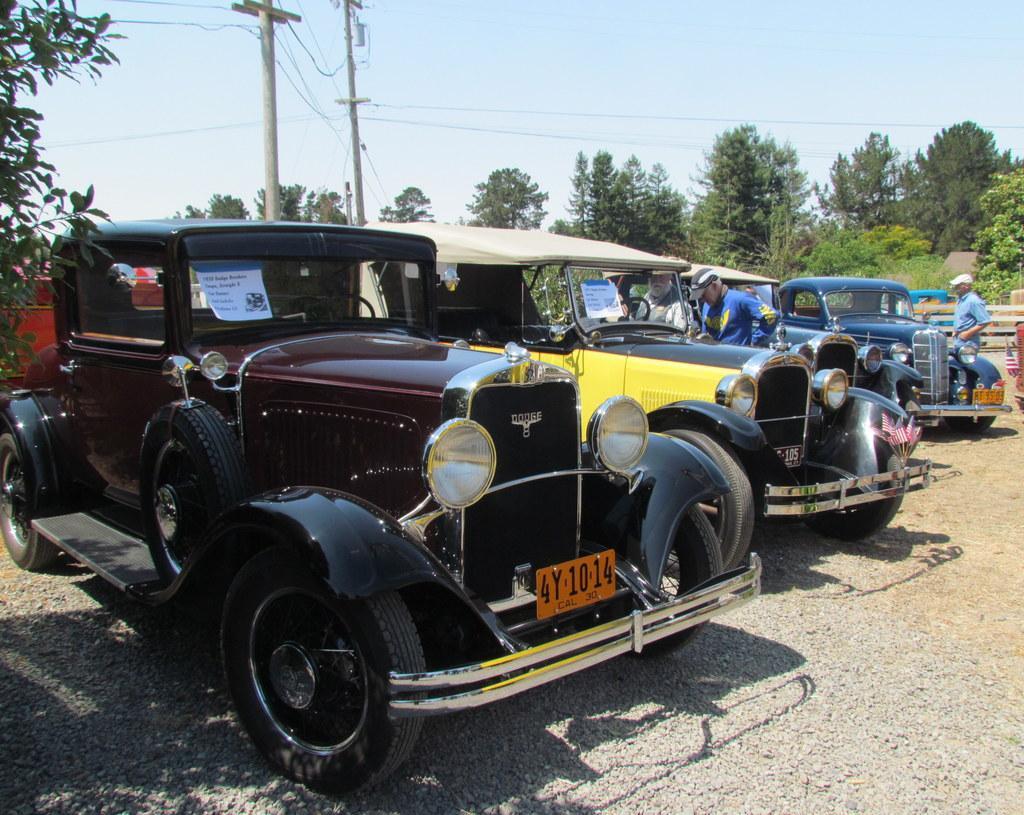Please provide a concise description of this image. There are vehicles in different colors parked on the ground. In the background, there are persons standing near vehicles, there are trees, poles which are having electrical lines and there is blue sky. 